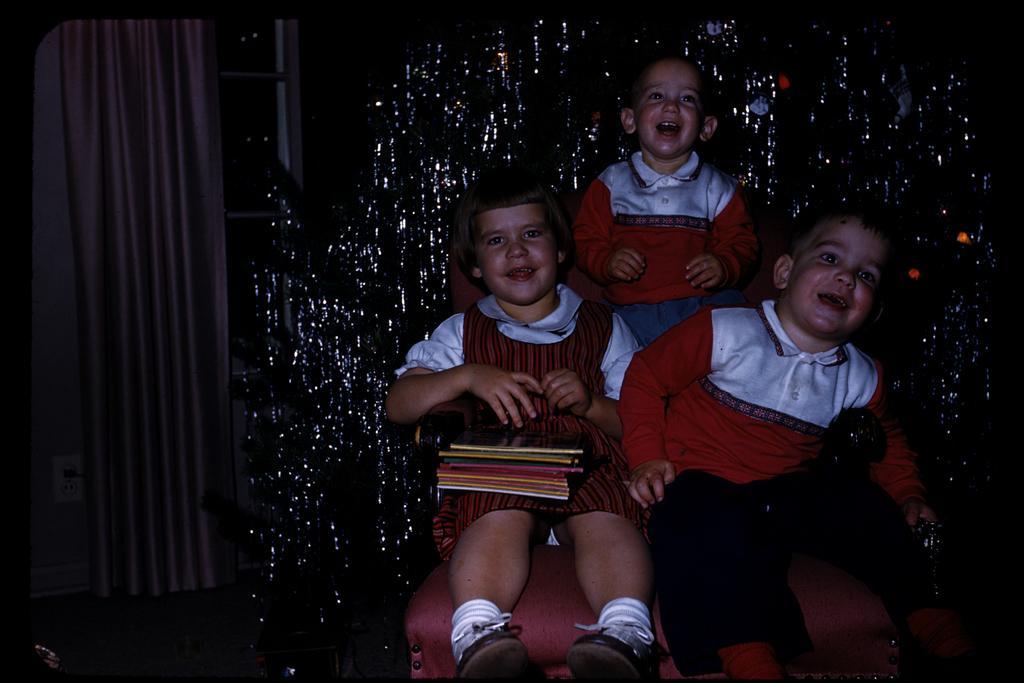Can you describe this image briefly? In this image I can see three children on the couch. I can see few objects on one of the child. I can see the curtain and there is a white and black color background. 